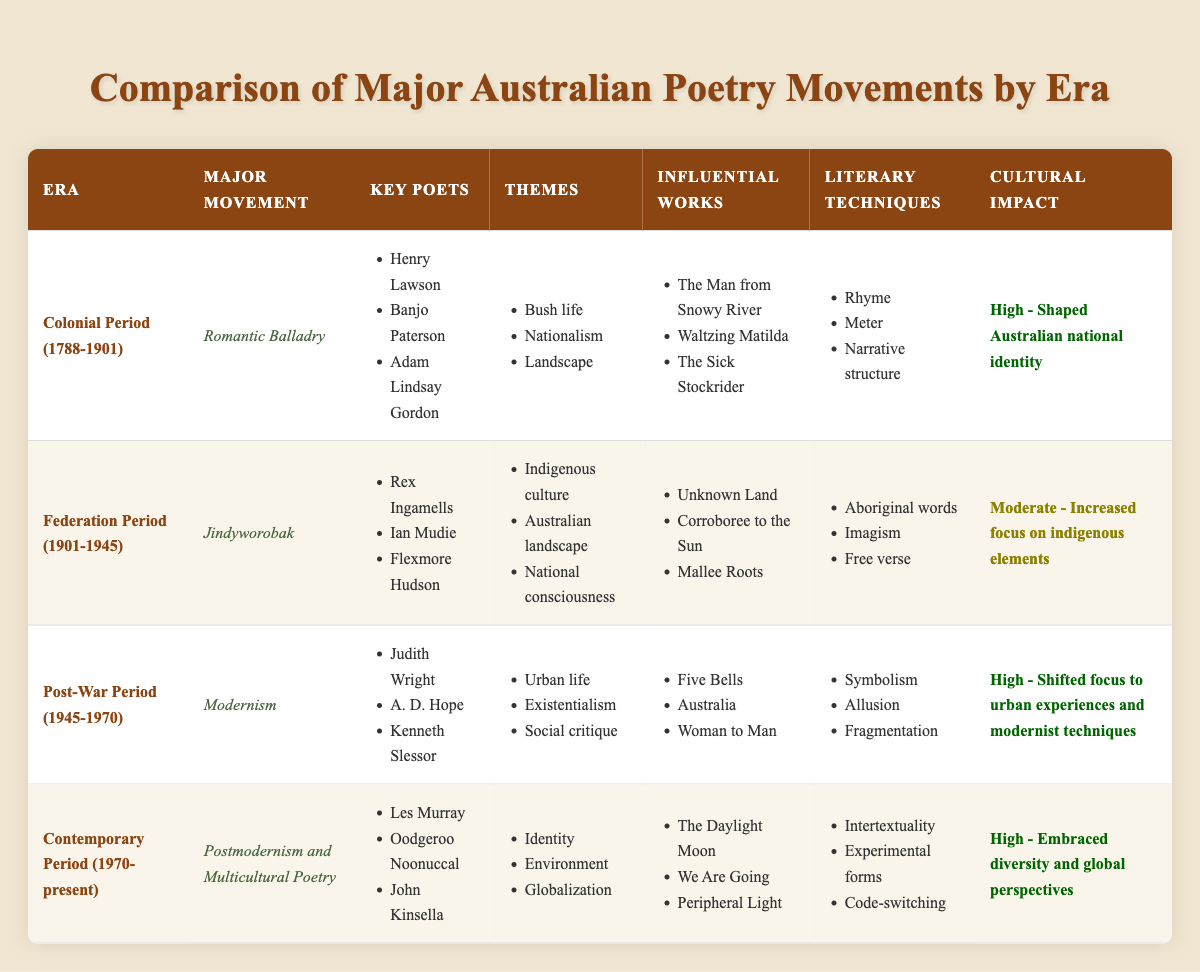What major movement is associated with the Post-War Period? The table indicates that the major movement during the Post-War Period (1945-1970) is Modernism.
Answer: Modernism Which key poet is associated with the Romantic Balladry movement? From the table, Henry Lawson, Banjo Paterson, and Adam Lindsay Gordon are listed as key poets for the Romantic Balladry movement in the Colonial Period.
Answer: Henry Lawson, Banjo Paterson, Adam Lindsay Gordon What themes are prevalent in the Jindyworobak movement? According to the table, the prevalent themes in the Jindyworobak movement include Indigenous culture, Australian landscape, and national consciousness.
Answer: Indigenous culture, Australian landscape, national consciousness Is it true that the Contemporary Period poetry addresses the theme of Globalization? The table shows that the themes of the Contemporary Period (1970-present) include Identity, Environment, and Globalization, indicating that this statement is true.
Answer: Yes Which era had the highest cultural impact according to the table? Both the Colonial Period and Contemporary Period are marked with "High" cultural impact, but the reason for the high impact in these eras needs to be considered differently—Colonial with shaping national identity and Contemporary with embracing diversity. As a result, both have equally high impact levels.
Answer: Colonial Period, Contemporary Period What literary techniques are common in the Modernism movement? The table lists the literary techniques associated with Modernism as Symbolism, Allusion, and Fragmentation for the Post-War Period (1945-1970).
Answer: Symbolism, Allusion, Fragmentation Which influential works are associated with the Colonial Period, and how many are there? The table mentions three influential works under the Colonial Period: "The Man from Snowy River," "Waltzing Matilda," and "The Sick Stockrider." Thus, there are a total of three influential works in that era.
Answer: Three How many key poets are associated with the Contemporary Period? In the table, the Contemporary Period lists three key poets—Les Murray, Oodgeroo Noonuccal, and John Kinsella, leading to a total of three key poets for that era.
Answer: Three Do the themes of Urban life and Social critique appear in any other poetry movement apart from Modernism? The themes of Urban life and Social critique are specifically listed under Modernism in the Post-War Period, indicating that they are not present in other movements as seen in the table.
Answer: No 